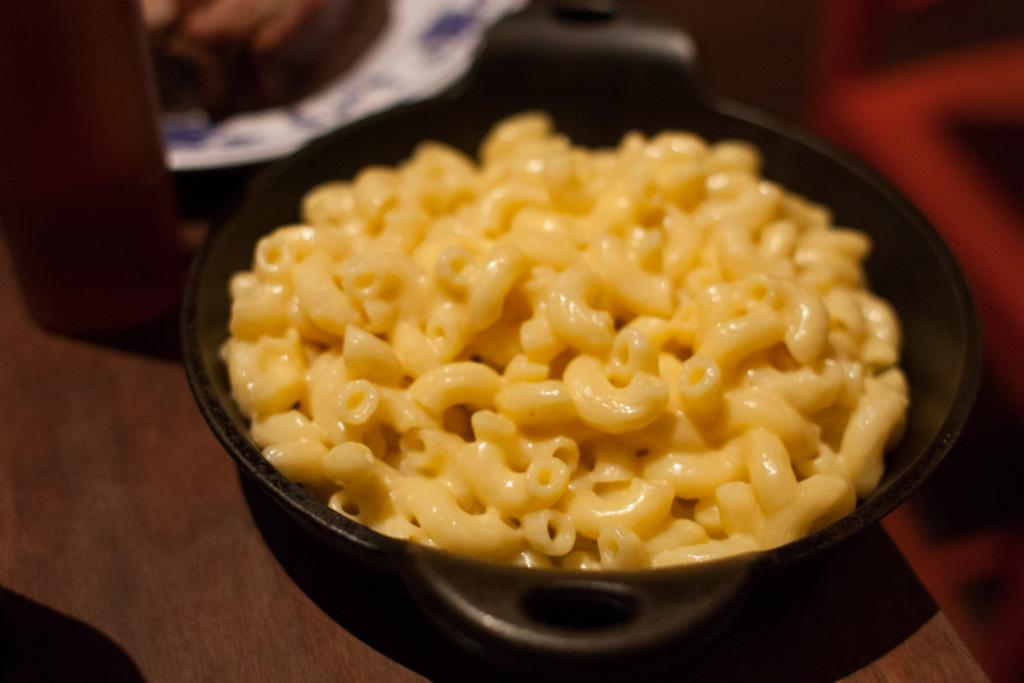What color is the bowl in the image? The bowl in the image is black. What is on the table in the image? There is a paper and other objects on the table in the image. What is inside the black bowl? The black bowl contains macaronis. What type of wrench is being used to open the account in the image? There is no wrench or account present in the image. How many books are visible on the table in the image? There is no mention of books in the image; the only objects mentioned are a paper and other unspecified objects. 